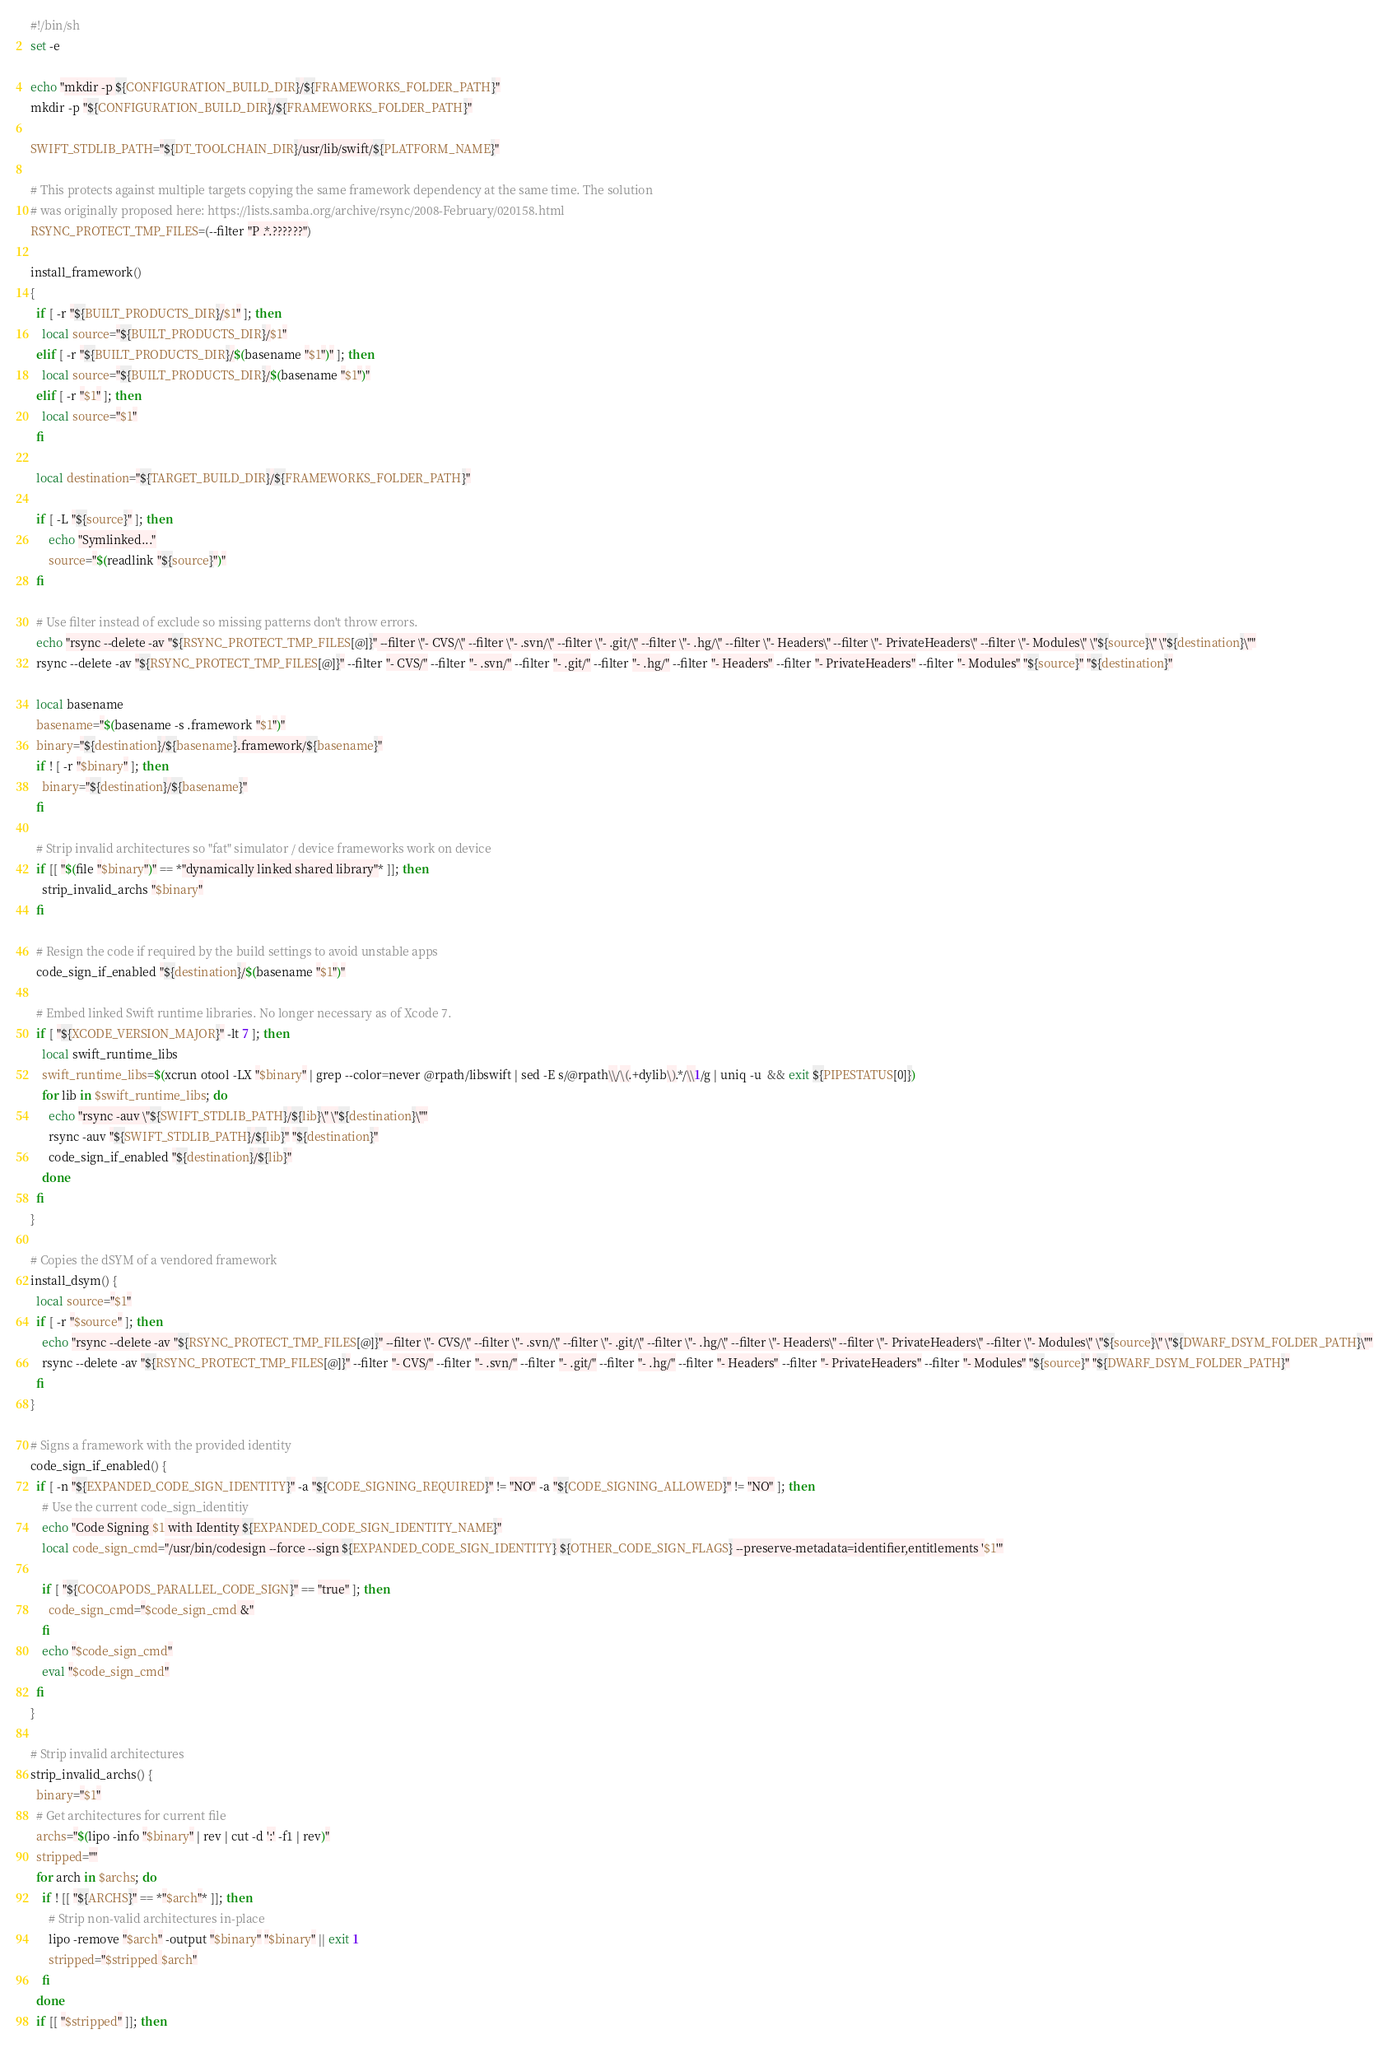Convert code to text. <code><loc_0><loc_0><loc_500><loc_500><_Bash_>#!/bin/sh
set -e

echo "mkdir -p ${CONFIGURATION_BUILD_DIR}/${FRAMEWORKS_FOLDER_PATH}"
mkdir -p "${CONFIGURATION_BUILD_DIR}/${FRAMEWORKS_FOLDER_PATH}"

SWIFT_STDLIB_PATH="${DT_TOOLCHAIN_DIR}/usr/lib/swift/${PLATFORM_NAME}"

# This protects against multiple targets copying the same framework dependency at the same time. The solution
# was originally proposed here: https://lists.samba.org/archive/rsync/2008-February/020158.html
RSYNC_PROTECT_TMP_FILES=(--filter "P .*.??????")

install_framework()
{
  if [ -r "${BUILT_PRODUCTS_DIR}/$1" ]; then
    local source="${BUILT_PRODUCTS_DIR}/$1"
  elif [ -r "${BUILT_PRODUCTS_DIR}/$(basename "$1")" ]; then
    local source="${BUILT_PRODUCTS_DIR}/$(basename "$1")"
  elif [ -r "$1" ]; then
    local source="$1"
  fi

  local destination="${TARGET_BUILD_DIR}/${FRAMEWORKS_FOLDER_PATH}"

  if [ -L "${source}" ]; then
      echo "Symlinked..."
      source="$(readlink "${source}")"
  fi

  # Use filter instead of exclude so missing patterns don't throw errors.
  echo "rsync --delete -av "${RSYNC_PROTECT_TMP_FILES[@]}" --filter \"- CVS/\" --filter \"- .svn/\" --filter \"- .git/\" --filter \"- .hg/\" --filter \"- Headers\" --filter \"- PrivateHeaders\" --filter \"- Modules\" \"${source}\" \"${destination}\""
  rsync --delete -av "${RSYNC_PROTECT_TMP_FILES[@]}" --filter "- CVS/" --filter "- .svn/" --filter "- .git/" --filter "- .hg/" --filter "- Headers" --filter "- PrivateHeaders" --filter "- Modules" "${source}" "${destination}"

  local basename
  basename="$(basename -s .framework "$1")"
  binary="${destination}/${basename}.framework/${basename}"
  if ! [ -r "$binary" ]; then
    binary="${destination}/${basename}"
  fi

  # Strip invalid architectures so "fat" simulator / device frameworks work on device
  if [[ "$(file "$binary")" == *"dynamically linked shared library"* ]]; then
    strip_invalid_archs "$binary"
  fi

  # Resign the code if required by the build settings to avoid unstable apps
  code_sign_if_enabled "${destination}/$(basename "$1")"

  # Embed linked Swift runtime libraries. No longer necessary as of Xcode 7.
  if [ "${XCODE_VERSION_MAJOR}" -lt 7 ]; then
    local swift_runtime_libs
    swift_runtime_libs=$(xcrun otool -LX "$binary" | grep --color=never @rpath/libswift | sed -E s/@rpath\\/\(.+dylib\).*/\\1/g | uniq -u  && exit ${PIPESTATUS[0]})
    for lib in $swift_runtime_libs; do
      echo "rsync -auv \"${SWIFT_STDLIB_PATH}/${lib}\" \"${destination}\""
      rsync -auv "${SWIFT_STDLIB_PATH}/${lib}" "${destination}"
      code_sign_if_enabled "${destination}/${lib}"
    done
  fi
}

# Copies the dSYM of a vendored framework
install_dsym() {
  local source="$1"
  if [ -r "$source" ]; then
    echo "rsync --delete -av "${RSYNC_PROTECT_TMP_FILES[@]}" --filter \"- CVS/\" --filter \"- .svn/\" --filter \"- .git/\" --filter \"- .hg/\" --filter \"- Headers\" --filter \"- PrivateHeaders\" --filter \"- Modules\" \"${source}\" \"${DWARF_DSYM_FOLDER_PATH}\""
    rsync --delete -av "${RSYNC_PROTECT_TMP_FILES[@]}" --filter "- CVS/" --filter "- .svn/" --filter "- .git/" --filter "- .hg/" --filter "- Headers" --filter "- PrivateHeaders" --filter "- Modules" "${source}" "${DWARF_DSYM_FOLDER_PATH}"
  fi
}

# Signs a framework with the provided identity
code_sign_if_enabled() {
  if [ -n "${EXPANDED_CODE_SIGN_IDENTITY}" -a "${CODE_SIGNING_REQUIRED}" != "NO" -a "${CODE_SIGNING_ALLOWED}" != "NO" ]; then
    # Use the current code_sign_identitiy
    echo "Code Signing $1 with Identity ${EXPANDED_CODE_SIGN_IDENTITY_NAME}"
    local code_sign_cmd="/usr/bin/codesign --force --sign ${EXPANDED_CODE_SIGN_IDENTITY} ${OTHER_CODE_SIGN_FLAGS} --preserve-metadata=identifier,entitlements '$1'"

    if [ "${COCOAPODS_PARALLEL_CODE_SIGN}" == "true" ]; then
      code_sign_cmd="$code_sign_cmd &"
    fi
    echo "$code_sign_cmd"
    eval "$code_sign_cmd"
  fi
}

# Strip invalid architectures
strip_invalid_archs() {
  binary="$1"
  # Get architectures for current file
  archs="$(lipo -info "$binary" | rev | cut -d ':' -f1 | rev)"
  stripped=""
  for arch in $archs; do
    if ! [[ "${ARCHS}" == *"$arch"* ]]; then
      # Strip non-valid architectures in-place
      lipo -remove "$arch" -output "$binary" "$binary" || exit 1
      stripped="$stripped $arch"
    fi
  done
  if [[ "$stripped" ]]; then</code> 